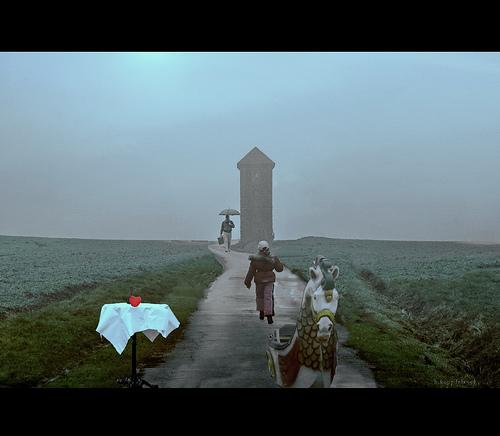Where is the horse?
Short answer required. Foreground. Is this person trying to escape from the rain?
Answer briefly. No. What is the main object in this photo?
Give a very brief answer. Horse. What sort of architecture is shown in the background?
Quick response, please. Tower. What color is the tablecloth?
Short answer required. White. Is this person avoiding puddles by walking on the middle strip?
Quick response, please. No. Is it a sunny day?
Keep it brief. No. 